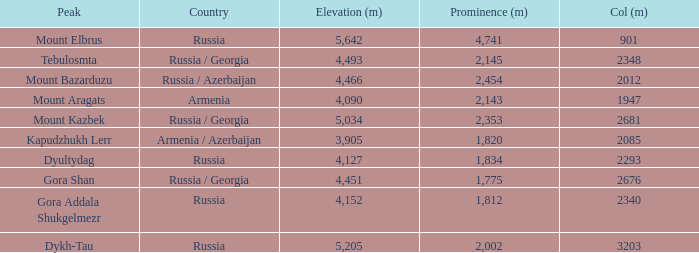With a Col (m) larger than 2012, what is Mount Kazbek's Prominence (m)? 2353.0. Can you parse all the data within this table? {'header': ['Peak', 'Country', 'Elevation (m)', 'Prominence (m)', 'Col (m)'], 'rows': [['Mount Elbrus', 'Russia', '5,642', '4,741', '901'], ['Tebulosmta', 'Russia / Georgia', '4,493', '2,145', '2348'], ['Mount Bazarduzu', 'Russia / Azerbaijan', '4,466', '2,454', '2012'], ['Mount Aragats', 'Armenia', '4,090', '2,143', '1947'], ['Mount Kazbek', 'Russia / Georgia', '5,034', '2,353', '2681'], ['Kapudzhukh Lerr', 'Armenia / Azerbaijan', '3,905', '1,820', '2085'], ['Dyultydag', 'Russia', '4,127', '1,834', '2293'], ['Gora Shan', 'Russia / Georgia', '4,451', '1,775', '2676'], ['Gora Addala Shukgelmezr', 'Russia', '4,152', '1,812', '2340'], ['Dykh-Tau', 'Russia', '5,205', '2,002', '3203']]} 